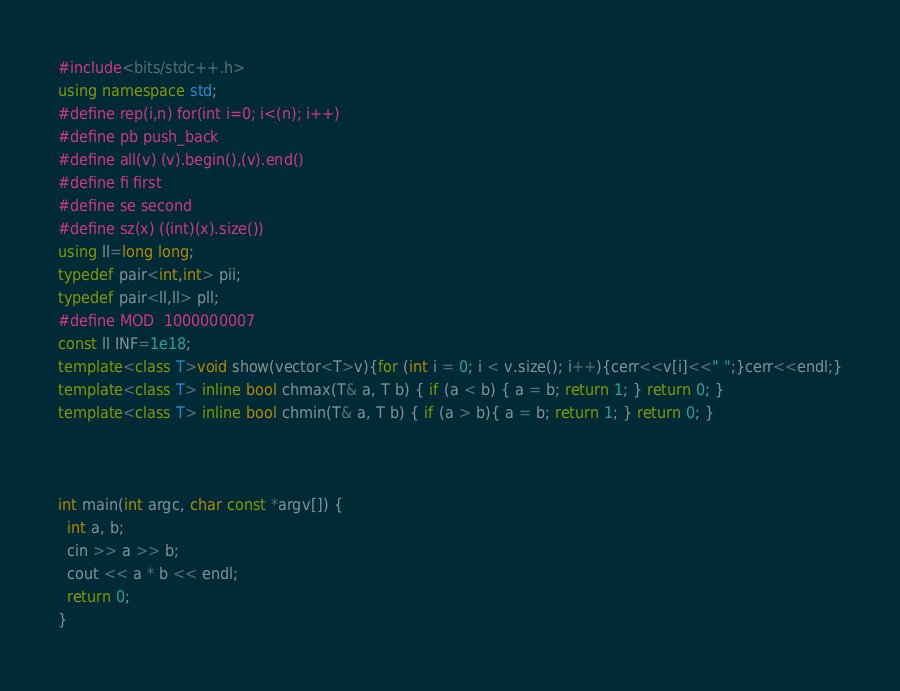<code> <loc_0><loc_0><loc_500><loc_500><_C++_>#include<bits/stdc++.h>
using namespace std;
#define rep(i,n) for(int i=0; i<(n); i++)
#define pb push_back
#define all(v) (v).begin(),(v).end()
#define fi first
#define se second
#define sz(x) ((int)(x).size())
using ll=long long;
typedef pair<int,int> pii;
typedef pair<ll,ll> pll;
#define MOD  1000000007
const ll INF=1e18;
template<class T>void show(vector<T>v){for (int i = 0; i < v.size(); i++){cerr<<v[i]<<" ";}cerr<<endl;}
template<class T> inline bool chmax(T& a, T b) { if (a < b) { a = b; return 1; } return 0; }
template<class T> inline bool chmin(T& a, T b) { if (a > b){ a = b; return 1; } return 0; }



int main(int argc, char const *argv[]) {
  int a, b;
  cin >> a >> b;
  cout << a * b << endl;
  return 0;
}</code> 